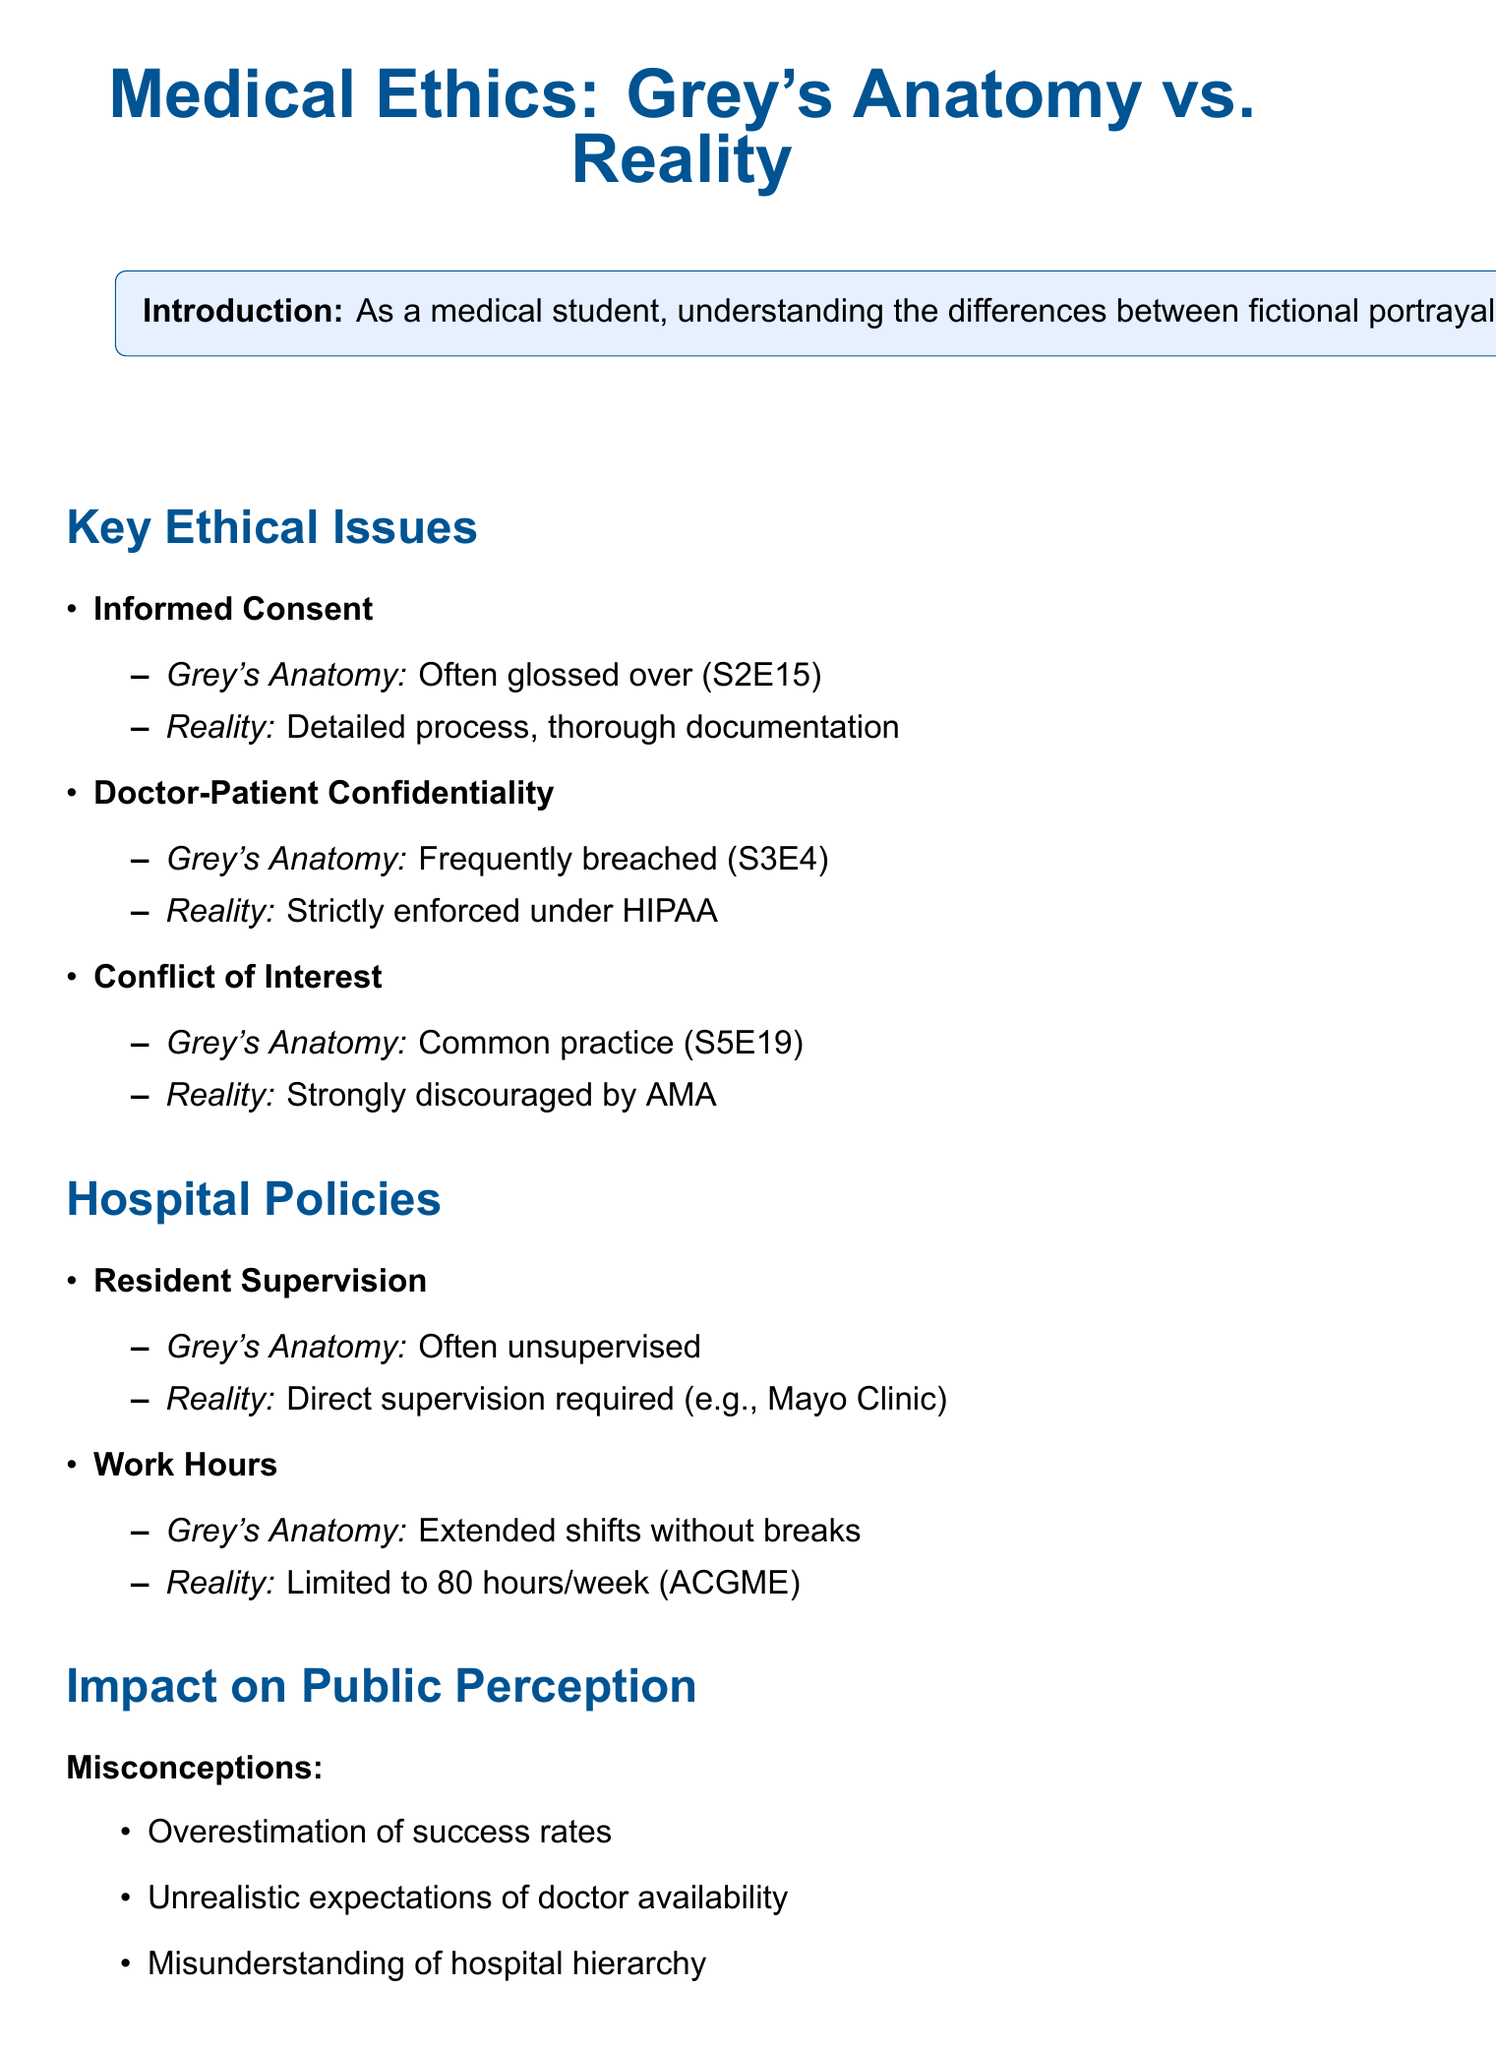What ethical issue involves obtaining patient permissions? The document states that informed consent is a key ethical issue discussed, particularly noting its portrayal in Grey's Anatomy where it is obtained hastily.
Answer: Informed consent Which episode features Izzie discussing a patient's condition without permission? The document references Season 3, Episode 4: 'What I Am' regarding the breach of doctor-patient confidentiality.
Answer: Season 3, Episode 4: 'What I Am' What is the real-world policy about treating family members? The document mentions that the American Medical Association Code of Ethics strongly discourages treating family or personal connections.
Answer: Strongly discouraged by AMA How does Grey's Anatomy portray resident supervision? The document describes that the portrayal shows residents often performing complex procedures unsupervised compared to real-world practices.
Answer: Unsat supervision What is the work hour limit for residents according to the ACGME? The document states that the Accreditation Council for Graduate Medical Education limits resident work hours to 80 hours per week.
Answer: 80 hours per week What positive aspect of Grey's Anatomy is mentioned in terms of public interest? The memo notes that one positive aspect is increased public interest in medical careers due to the show's portrayal of medicine.
Answer: Increased interest in medical careers 